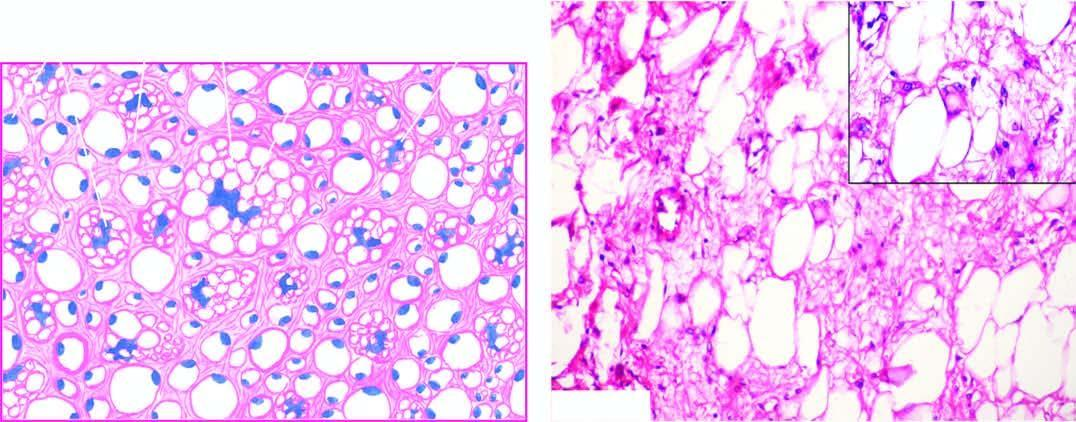what does inset in the right photomicrograph show?
Answer the question using a single word or phrase. Close-up view of a typical lipoblast having multivacuolated cytoplasm indenting the atypical nucleus 